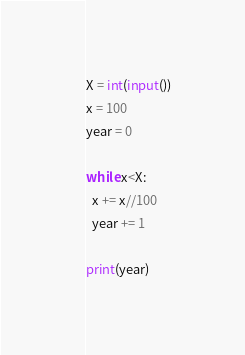Convert code to text. <code><loc_0><loc_0><loc_500><loc_500><_Python_>X = int(input())
x = 100
year = 0

while x<X:
  x += x//100
  year += 1

print(year)</code> 